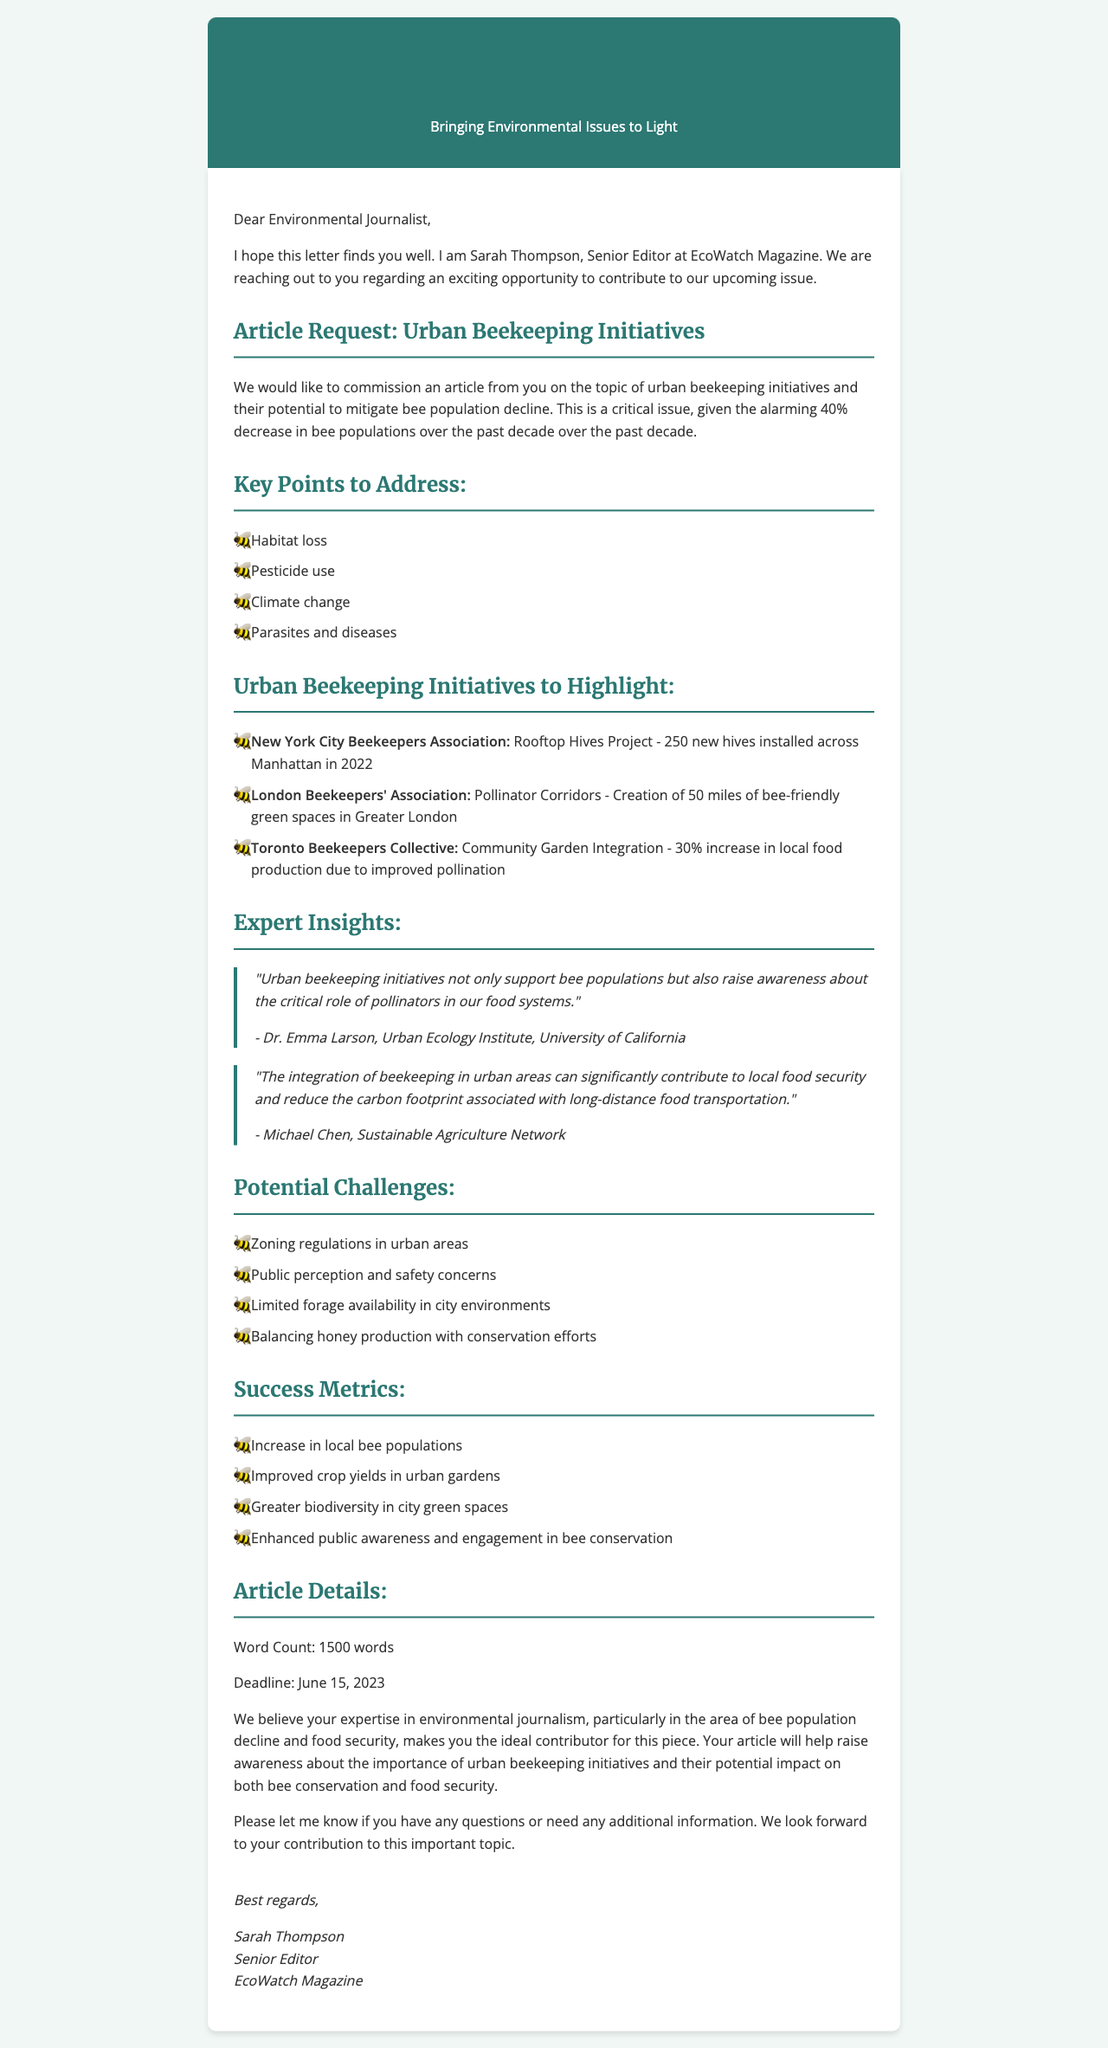What is the name of the editor? The editor's name is mentioned in the letter header as Sarah Thompson.
Answer: Sarah Thompson What is the deadline for the article? The deadline for the article is stated in the article details section.
Answer: June 15, 2023 How many rooftop hives were installed in Manhattan? The letter provides the impact of the Rooftop Hives Project as 250 new hives installed.
Answer: 250 What percentage increase in local food production is attributed to the Toronto Beekeepers Collective? The document mentions a 30% increase in local food production due to their initiative.
Answer: 30% What are some potential challenges listed in the letter? The letter outlines challenges such as zoning regulations and public perception among others.
Answer: Zoning regulations Which organization is Michael Chen affiliated with? Michael Chen's affiliation is noted under the expert quotes section.
Answer: Sustainable Agriculture Network What is the word count specified for the article? The word count for the article is explicitly mentioned in the article details.
Answer: 1500 words What role do urban beekeeping initiatives play in food security? The letter suggests that urban beekeeping initiatives can significantly contribute to local food security as inferred from the expert insights.
Answer: Contribute to local food security What section details the expert insights? The expert insights are provided in a dedicated section titled "Expert Insights."
Answer: Expert Insights 